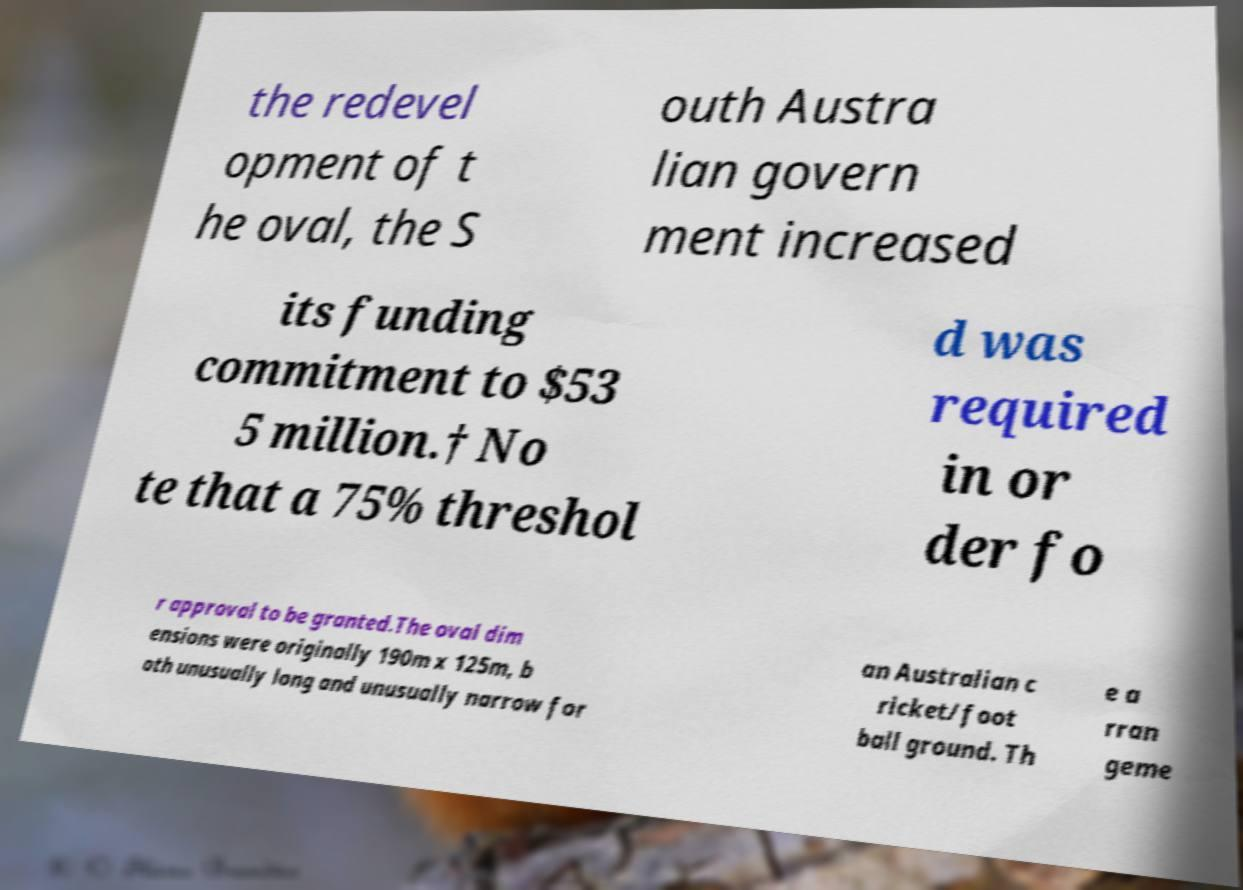Please read and relay the text visible in this image. What does it say? the redevel opment of t he oval, the S outh Austra lian govern ment increased its funding commitment to $53 5 million.† No te that a 75% threshol d was required in or der fo r approval to be granted.The oval dim ensions were originally 190m x 125m, b oth unusually long and unusually narrow for an Australian c ricket/foot ball ground. Th e a rran geme 